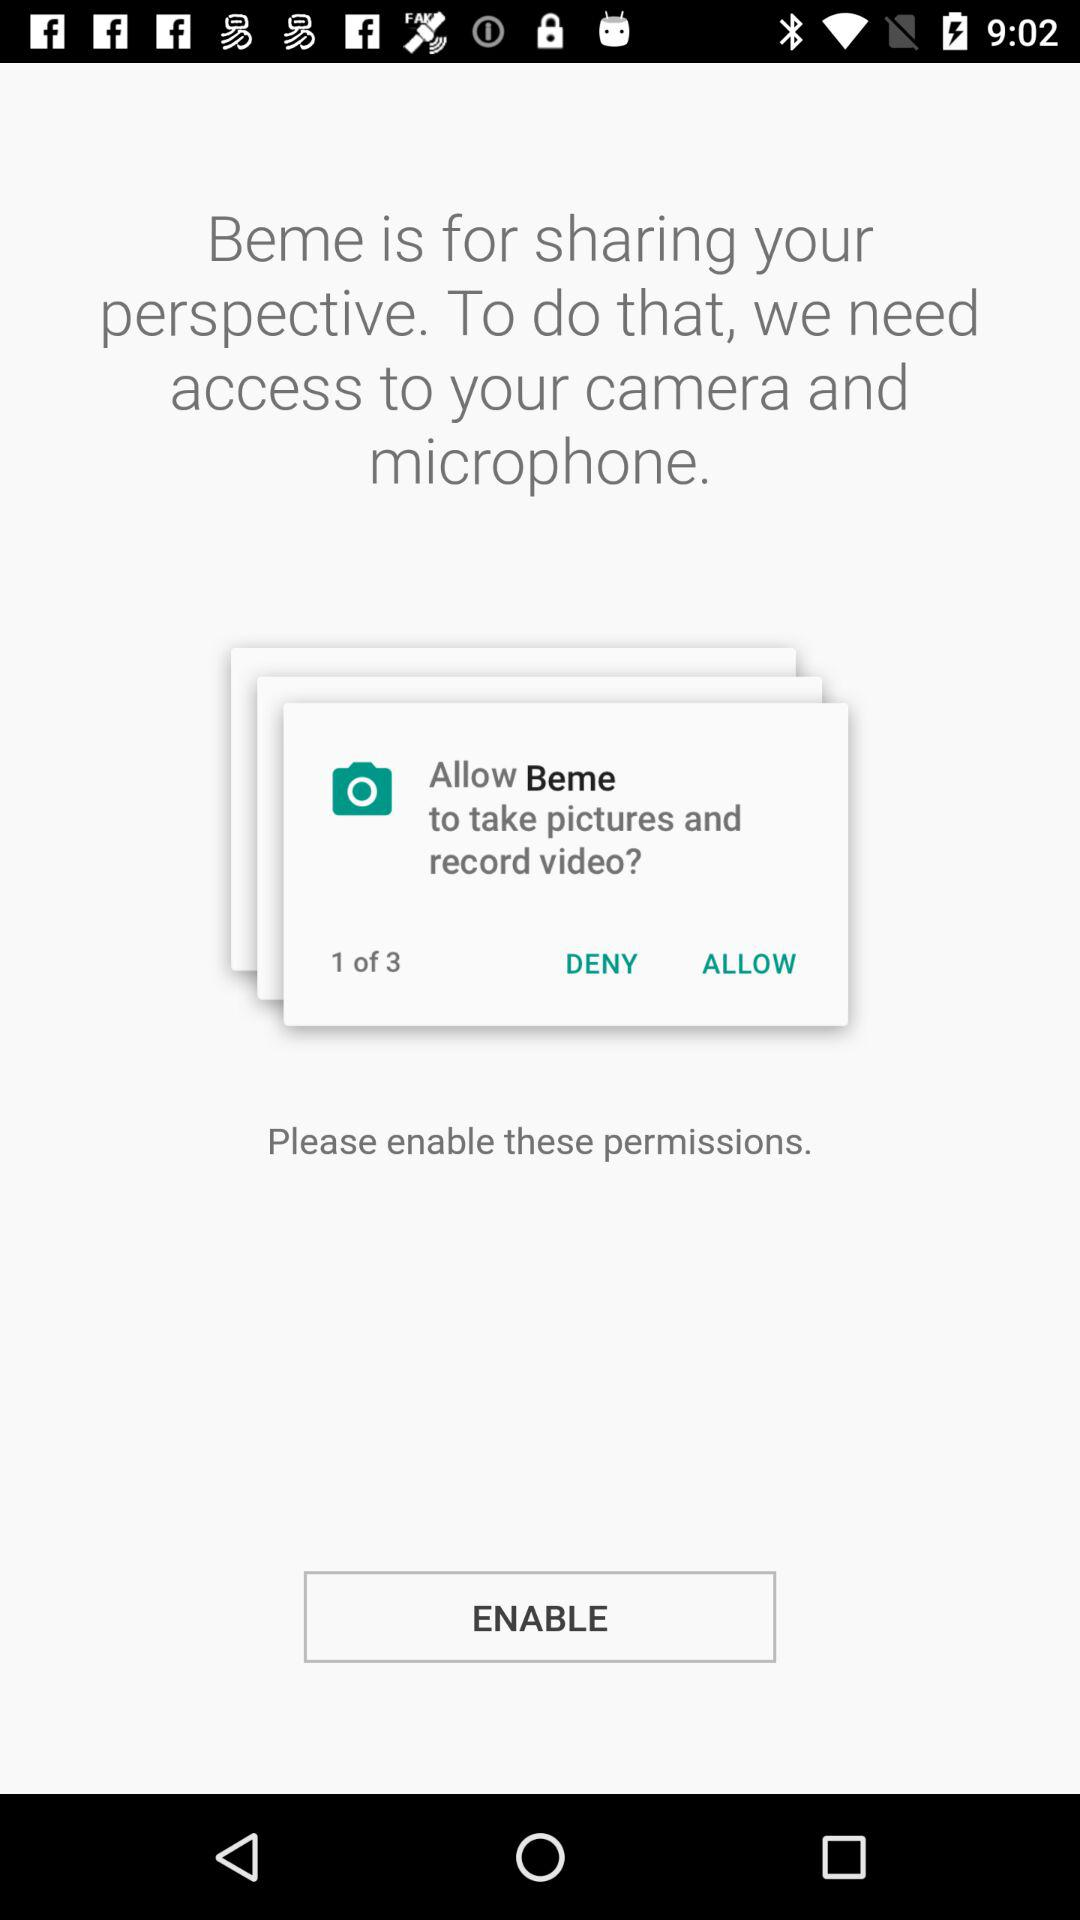At what number of permission are we right now? You are right now at the first permission. 